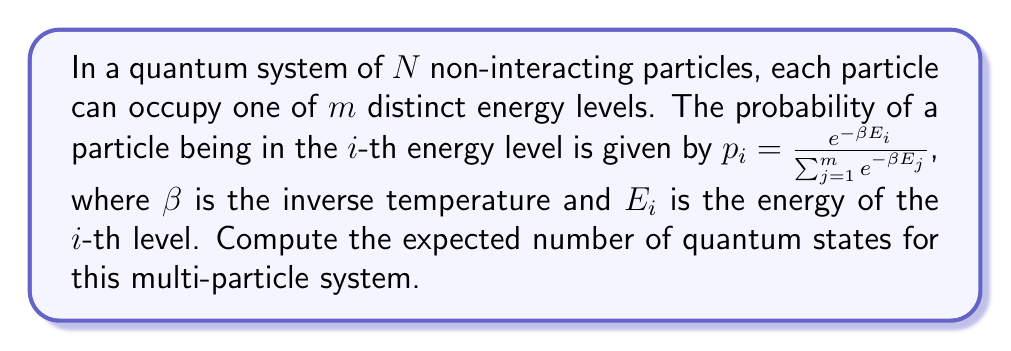Give your solution to this math problem. Let's approach this step-by-step:

1) In quantum mechanics, the total number of states for a system of $N$ distinguishable particles, each with $m$ possible states, is $m^N$.

2) However, we're interested in the expected number of states. This is equivalent to calculating the number of microstates in statistical mechanics.

3) For indistinguishable particles, we need to use the multinomial distribution. The number of ways to distribute $N$ particles among $m$ energy levels is given by:

   $$\frac{N!}{n_1! n_2! ... n_m!}$$

   where $n_i$ is the number of particles in the $i$-th energy level.

4) The probability of a particular configuration is:

   $$P(n_1, n_2, ..., n_m) = \frac{N!}{n_1! n_2! ... n_m!} p_1^{n_1} p_2^{n_2} ... p_m^{n_m}$$

5) The expected number of states is the sum of this probability over all possible configurations:

   $$\langle \Omega \rangle = \sum_{n_1 + n_2 + ... + n_m = N} \frac{N!}{n_1! n_2! ... n_m!} p_1^{n_1} p_2^{n_2} ... p_m^{n_m}$$

6) This sum is exactly the multinomial expansion of $(p_1 + p_2 + ... + p_m)^N$.

7) Since the $p_i$ are probabilities, we know that $\sum_{i=1}^m p_i = 1$.

8) Therefore, the expected number of states is simply:

   $$\langle \Omega \rangle = (p_1 + p_2 + ... + p_m)^N = 1^N = 1$$

This result might seem surprising, but it's correct. It means that on average, we expect to find the system in one particular state, even though many states are possible.
Answer: $\langle \Omega \rangle = 1$ 